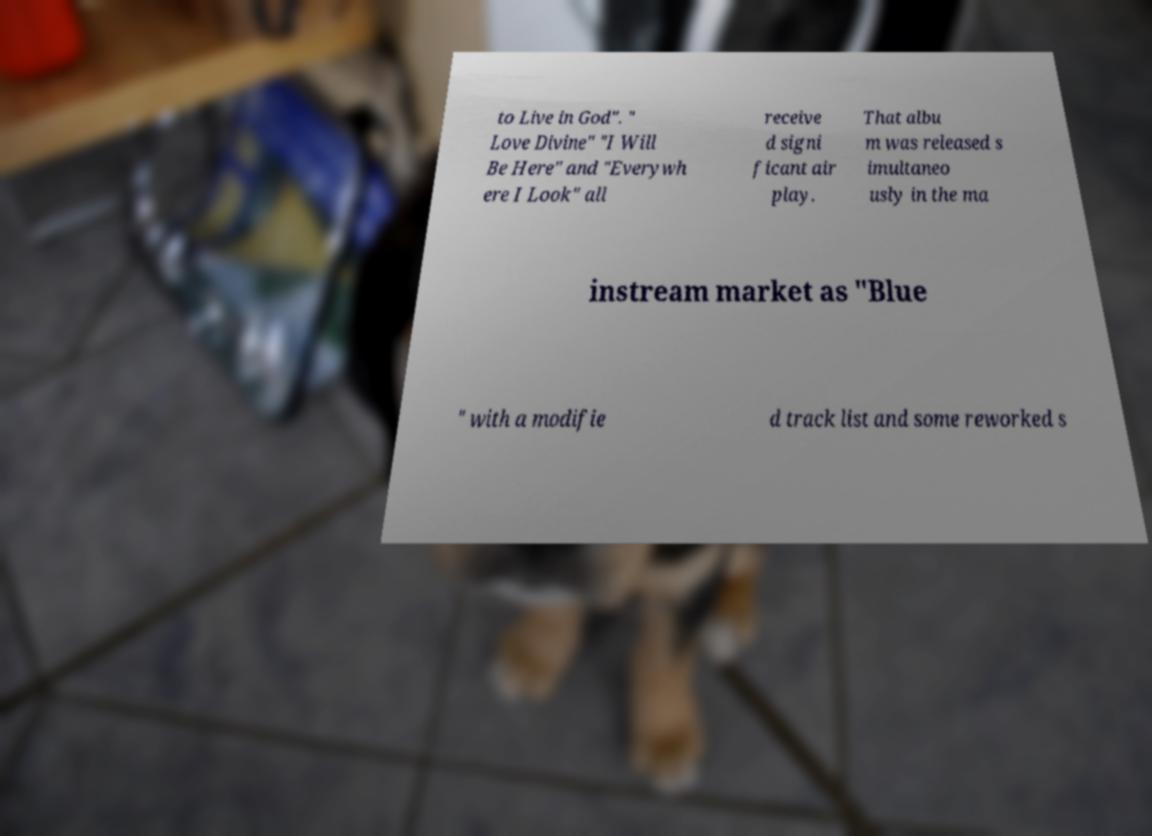Could you extract and type out the text from this image? to Live in God". " Love Divine" "I Will Be Here" and "Everywh ere I Look" all receive d signi ficant air play. That albu m was released s imultaneo usly in the ma instream market as "Blue " with a modifie d track list and some reworked s 